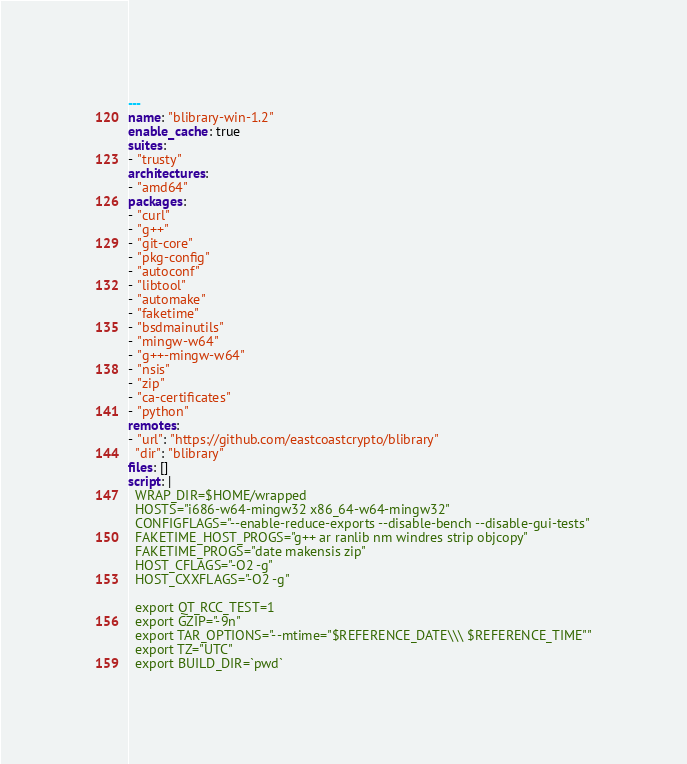<code> <loc_0><loc_0><loc_500><loc_500><_YAML_>---
name: "blibrary-win-1.2"
enable_cache: true
suites:
- "trusty"
architectures:
- "amd64"
packages:
- "curl"
- "g++"
- "git-core"
- "pkg-config"
- "autoconf"
- "libtool"
- "automake"
- "faketime"
- "bsdmainutils"
- "mingw-w64"
- "g++-mingw-w64"
- "nsis"
- "zip"
- "ca-certificates"
- "python"
remotes:
- "url": "https://github.com/eastcoastcrypto/blibrary"
  "dir": "blibrary"
files: []
script: |
  WRAP_DIR=$HOME/wrapped
  HOSTS="i686-w64-mingw32 x86_64-w64-mingw32"
  CONFIGFLAGS="--enable-reduce-exports --disable-bench --disable-gui-tests"
  FAKETIME_HOST_PROGS="g++ ar ranlib nm windres strip objcopy"
  FAKETIME_PROGS="date makensis zip"
  HOST_CFLAGS="-O2 -g"
  HOST_CXXFLAGS="-O2 -g"

  export QT_RCC_TEST=1
  export GZIP="-9n"
  export TAR_OPTIONS="--mtime="$REFERENCE_DATE\\\ $REFERENCE_TIME""
  export TZ="UTC"
  export BUILD_DIR=`pwd`</code> 